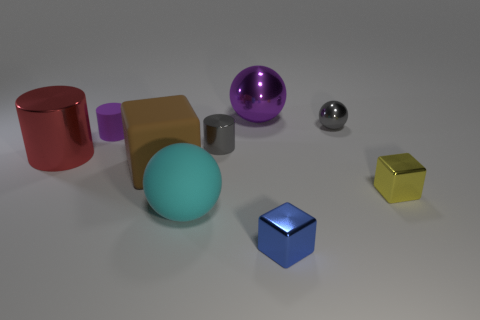Subtract all tiny yellow shiny blocks. How many blocks are left? 2 Subtract 1 blocks. How many blocks are left? 2 Subtract all red spheres. Subtract all cyan cylinders. How many spheres are left? 3 Subtract all balls. How many objects are left? 6 Add 3 small gray shiny spheres. How many small gray shiny spheres exist? 4 Subtract 0 green cylinders. How many objects are left? 9 Subtract all large brown matte objects. Subtract all big shiny cylinders. How many objects are left? 7 Add 7 gray metal balls. How many gray metal balls are left? 8 